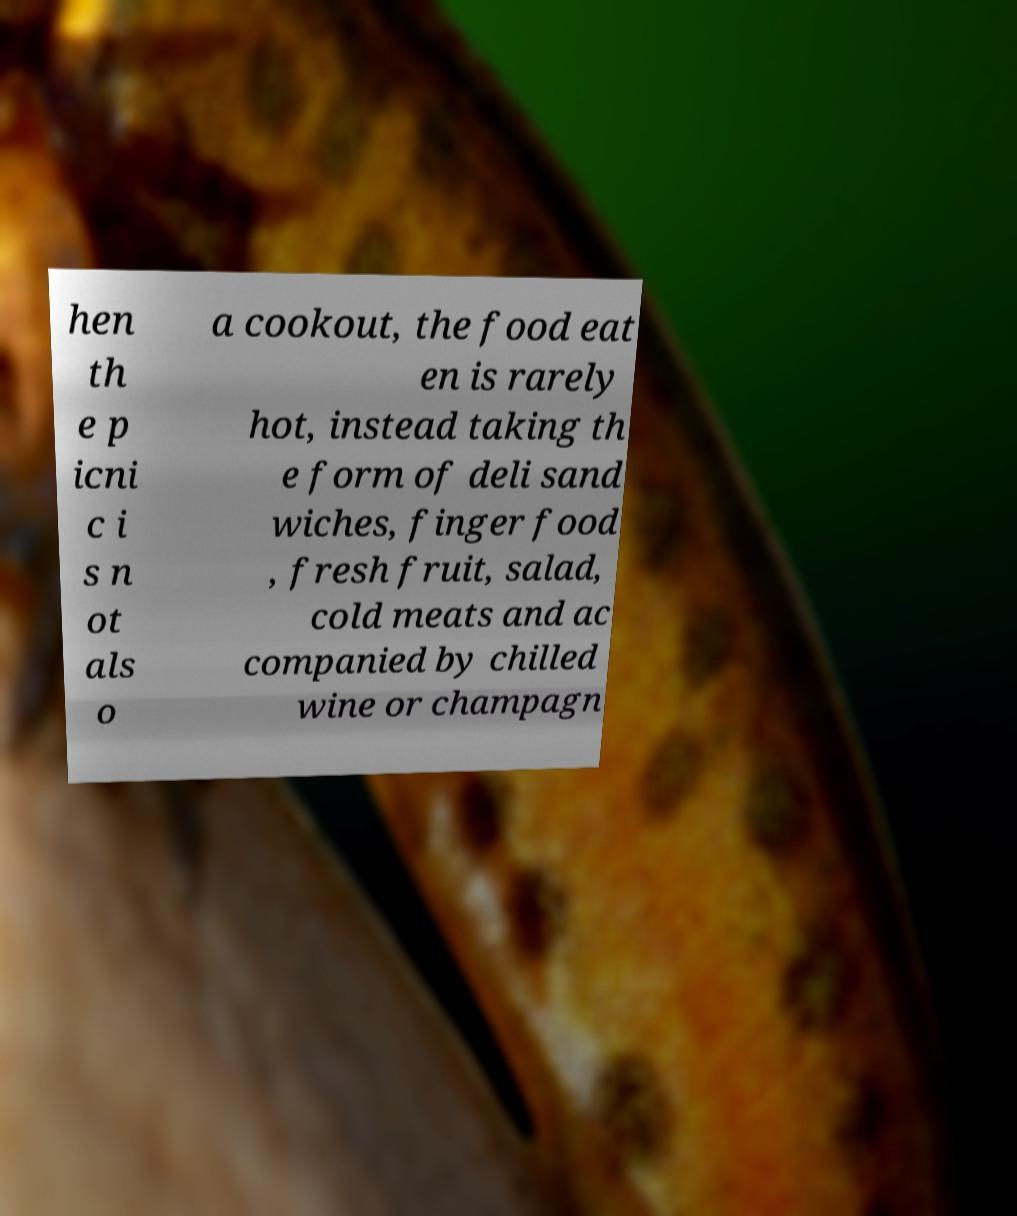I need the written content from this picture converted into text. Can you do that? hen th e p icni c i s n ot als o a cookout, the food eat en is rarely hot, instead taking th e form of deli sand wiches, finger food , fresh fruit, salad, cold meats and ac companied by chilled wine or champagn 